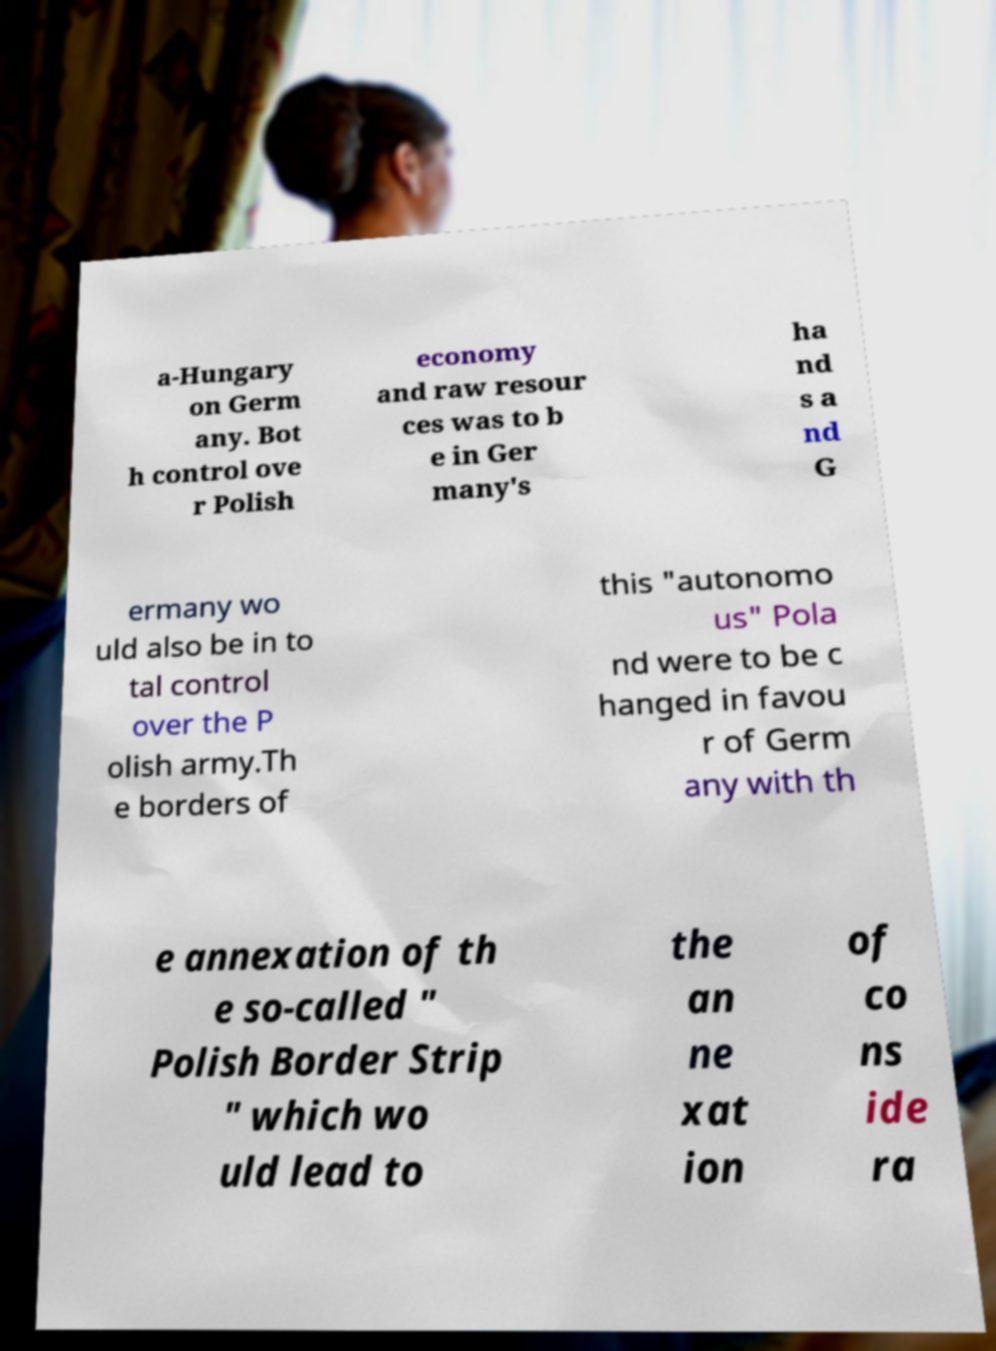Please read and relay the text visible in this image. What does it say? a-Hungary on Germ any. Bot h control ove r Polish economy and raw resour ces was to b e in Ger many's ha nd s a nd G ermany wo uld also be in to tal control over the P olish army.Th e borders of this "autonomo us" Pola nd were to be c hanged in favou r of Germ any with th e annexation of th e so-called " Polish Border Strip " which wo uld lead to the an ne xat ion of co ns ide ra 